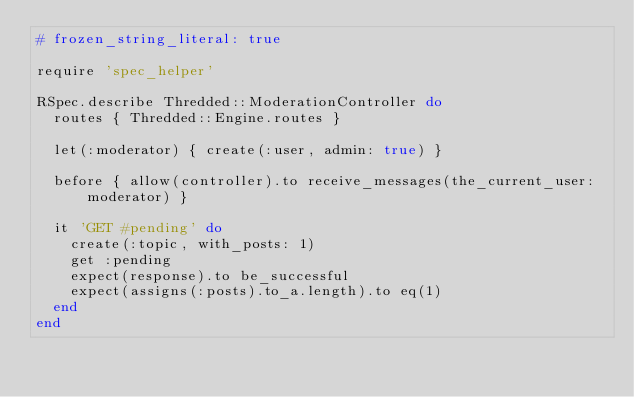Convert code to text. <code><loc_0><loc_0><loc_500><loc_500><_Ruby_># frozen_string_literal: true

require 'spec_helper'

RSpec.describe Thredded::ModerationController do
  routes { Thredded::Engine.routes }

  let(:moderator) { create(:user, admin: true) }

  before { allow(controller).to receive_messages(the_current_user: moderator) }

  it 'GET #pending' do
    create(:topic, with_posts: 1)
    get :pending
    expect(response).to be_successful
    expect(assigns(:posts).to_a.length).to eq(1)
  end
end
</code> 